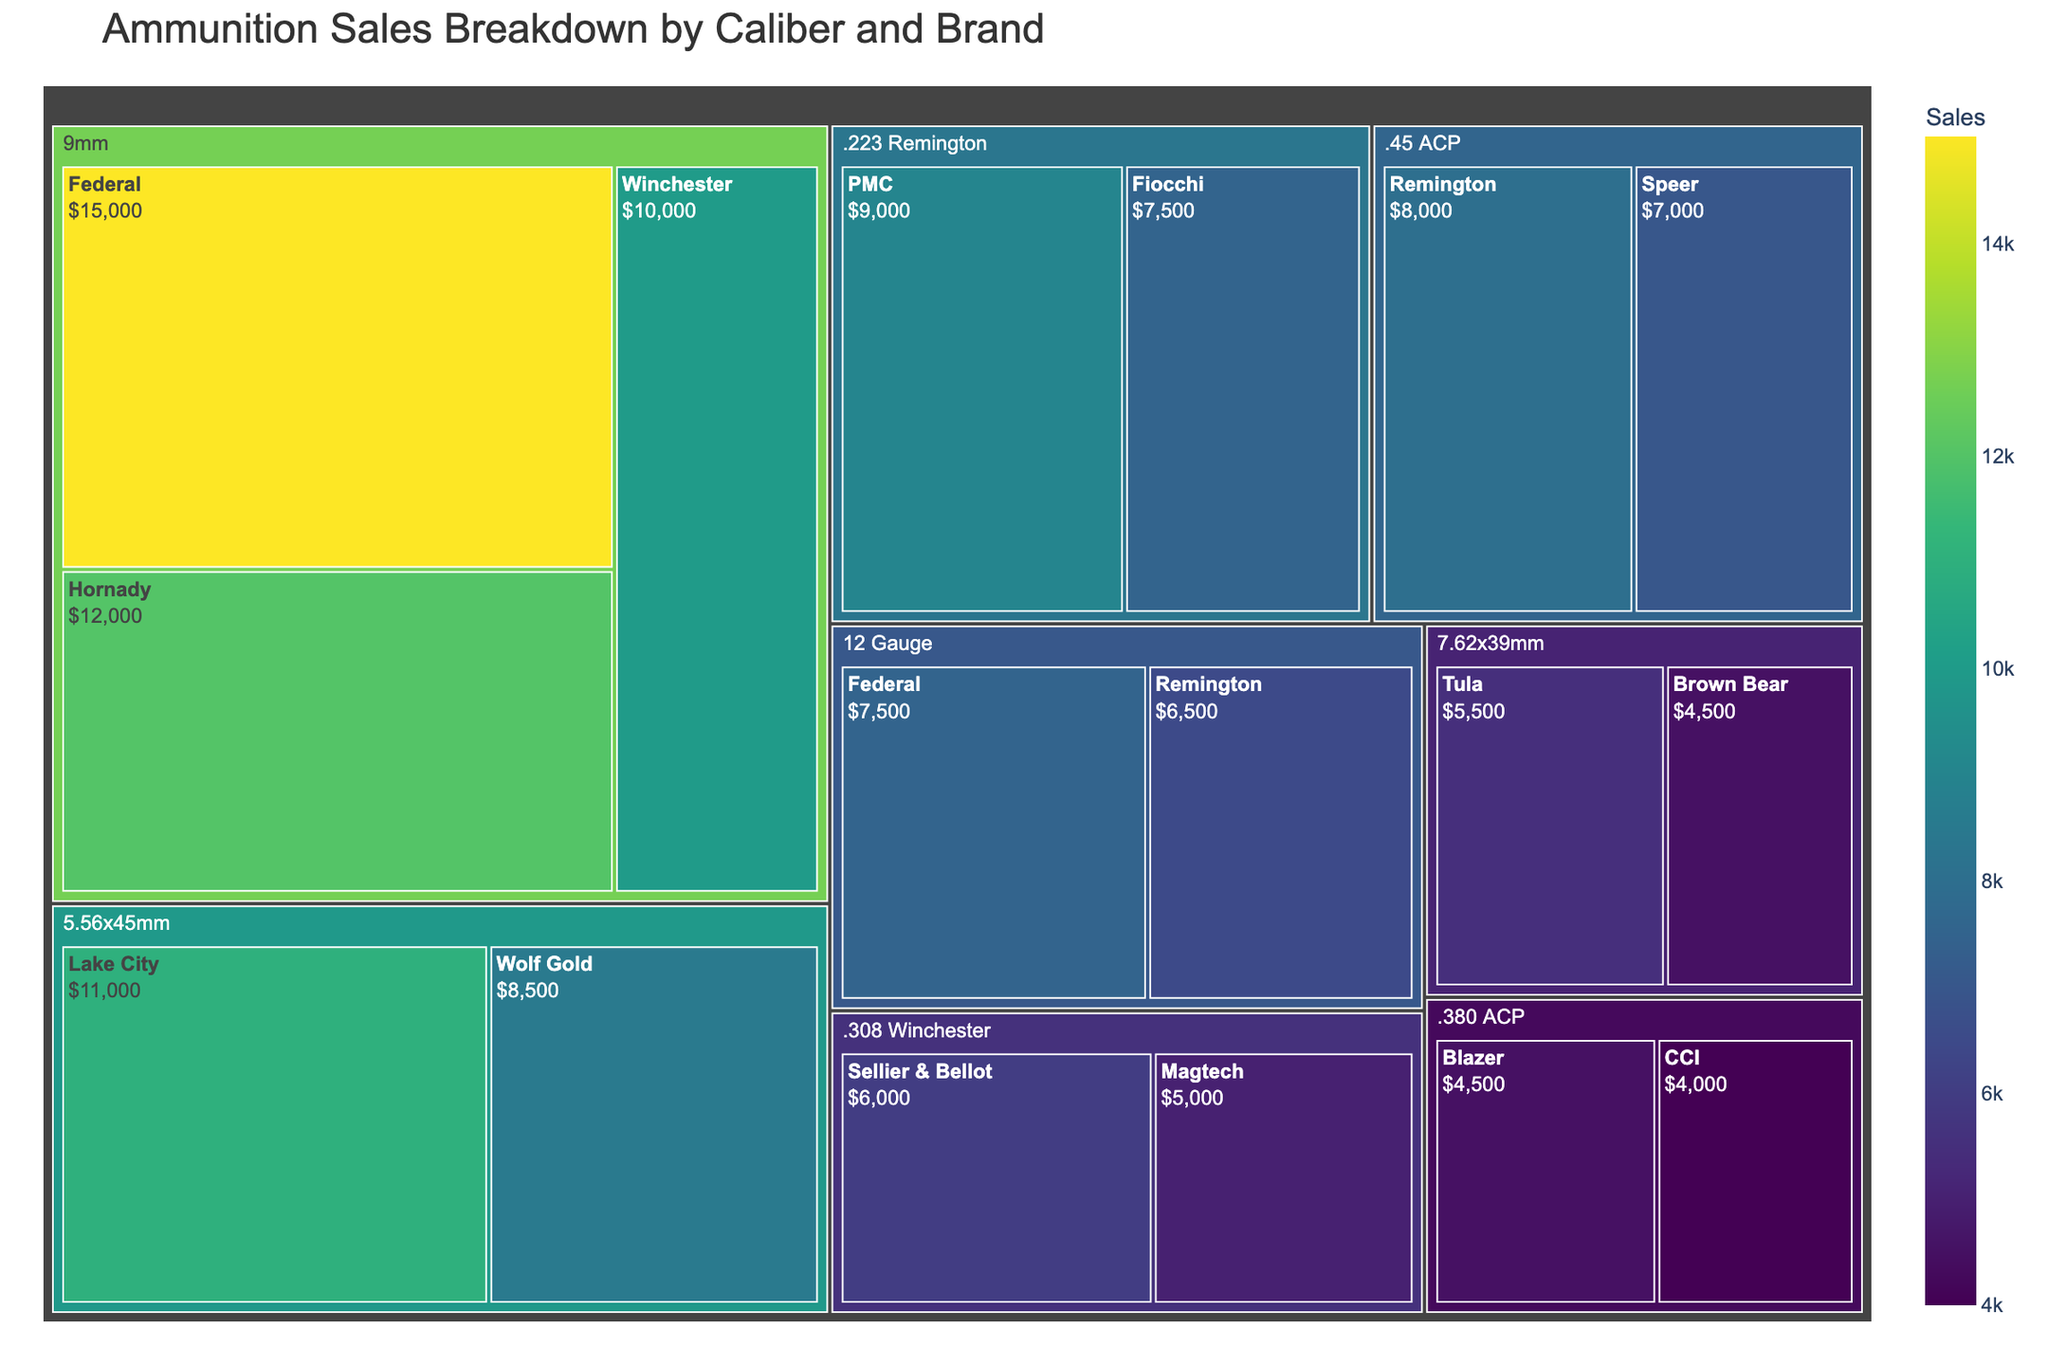Which caliber has the highest total sales? To find the caliber with the highest total sales, look for the largest block representing a caliber. The 9mm largest block indicates it has the highest sales.
Answer: 9mm Which caliber has the lowest total sales? Look for the smallest block representing a caliber. The smallest block belongs to .380 ACP.
Answer: .380 ACP Which brand within the 9mm caliber has the highest sales? Inspect the sub-blocks within the 9mm block. The largest sub-block belongs to Federal.
Answer: Federal What is the total sales for the .45 ACP caliber? Add the sales from the Remington and Speer brands within the .45 ACP block. \(8000 + 7000 = 15000\)
Answer: 15000 Which has more sales, the 12 Gauge or the .223 Remington? Compare the blocks for 12 Gauge and .223 Remington. 12 Gauge has \(7500 + 6500 = 14000\) sales, while .223 Remington has \(9000 + 7500 = 16500\) sales.
Answer: .223 Remington Which brand has the highest sales overall? Look for the largest sub-block in the entire Treemap. This block belongs to the Federal brand within the 9mm caliber.
Answer: Federal What are the combined sales of Federal ammunition across all calibers? Sum the sales of Federal in 9mm (15000) and 12 Gauge (7500). \(15000 + 7500 = 22500\)
Answer: 22500 How do the sales of 5.56x45mm compare to the sales of 7.62x39mm? Calculate and compare the total sales of 5.56x45mm and 7.62x39mm. \(11000 + 8500 = 19500\) for 5.56x45mm, \(5500 + 4500 = 10000\) for 7.62x39mm.
Answer: Greater Which brand in the .308 Winchester caliber has the lowest sales? Inspect the sub-blocks within the .308 Winchester block. The smallest sub-block belongs to Magtech.
Answer: Magtech What is the total sales for brands starting with the letter "F"? Sum the sales of Federal (22500), Fiocchi (7500). \(22500 + 7500 = 30000\)
Answer: 30000 